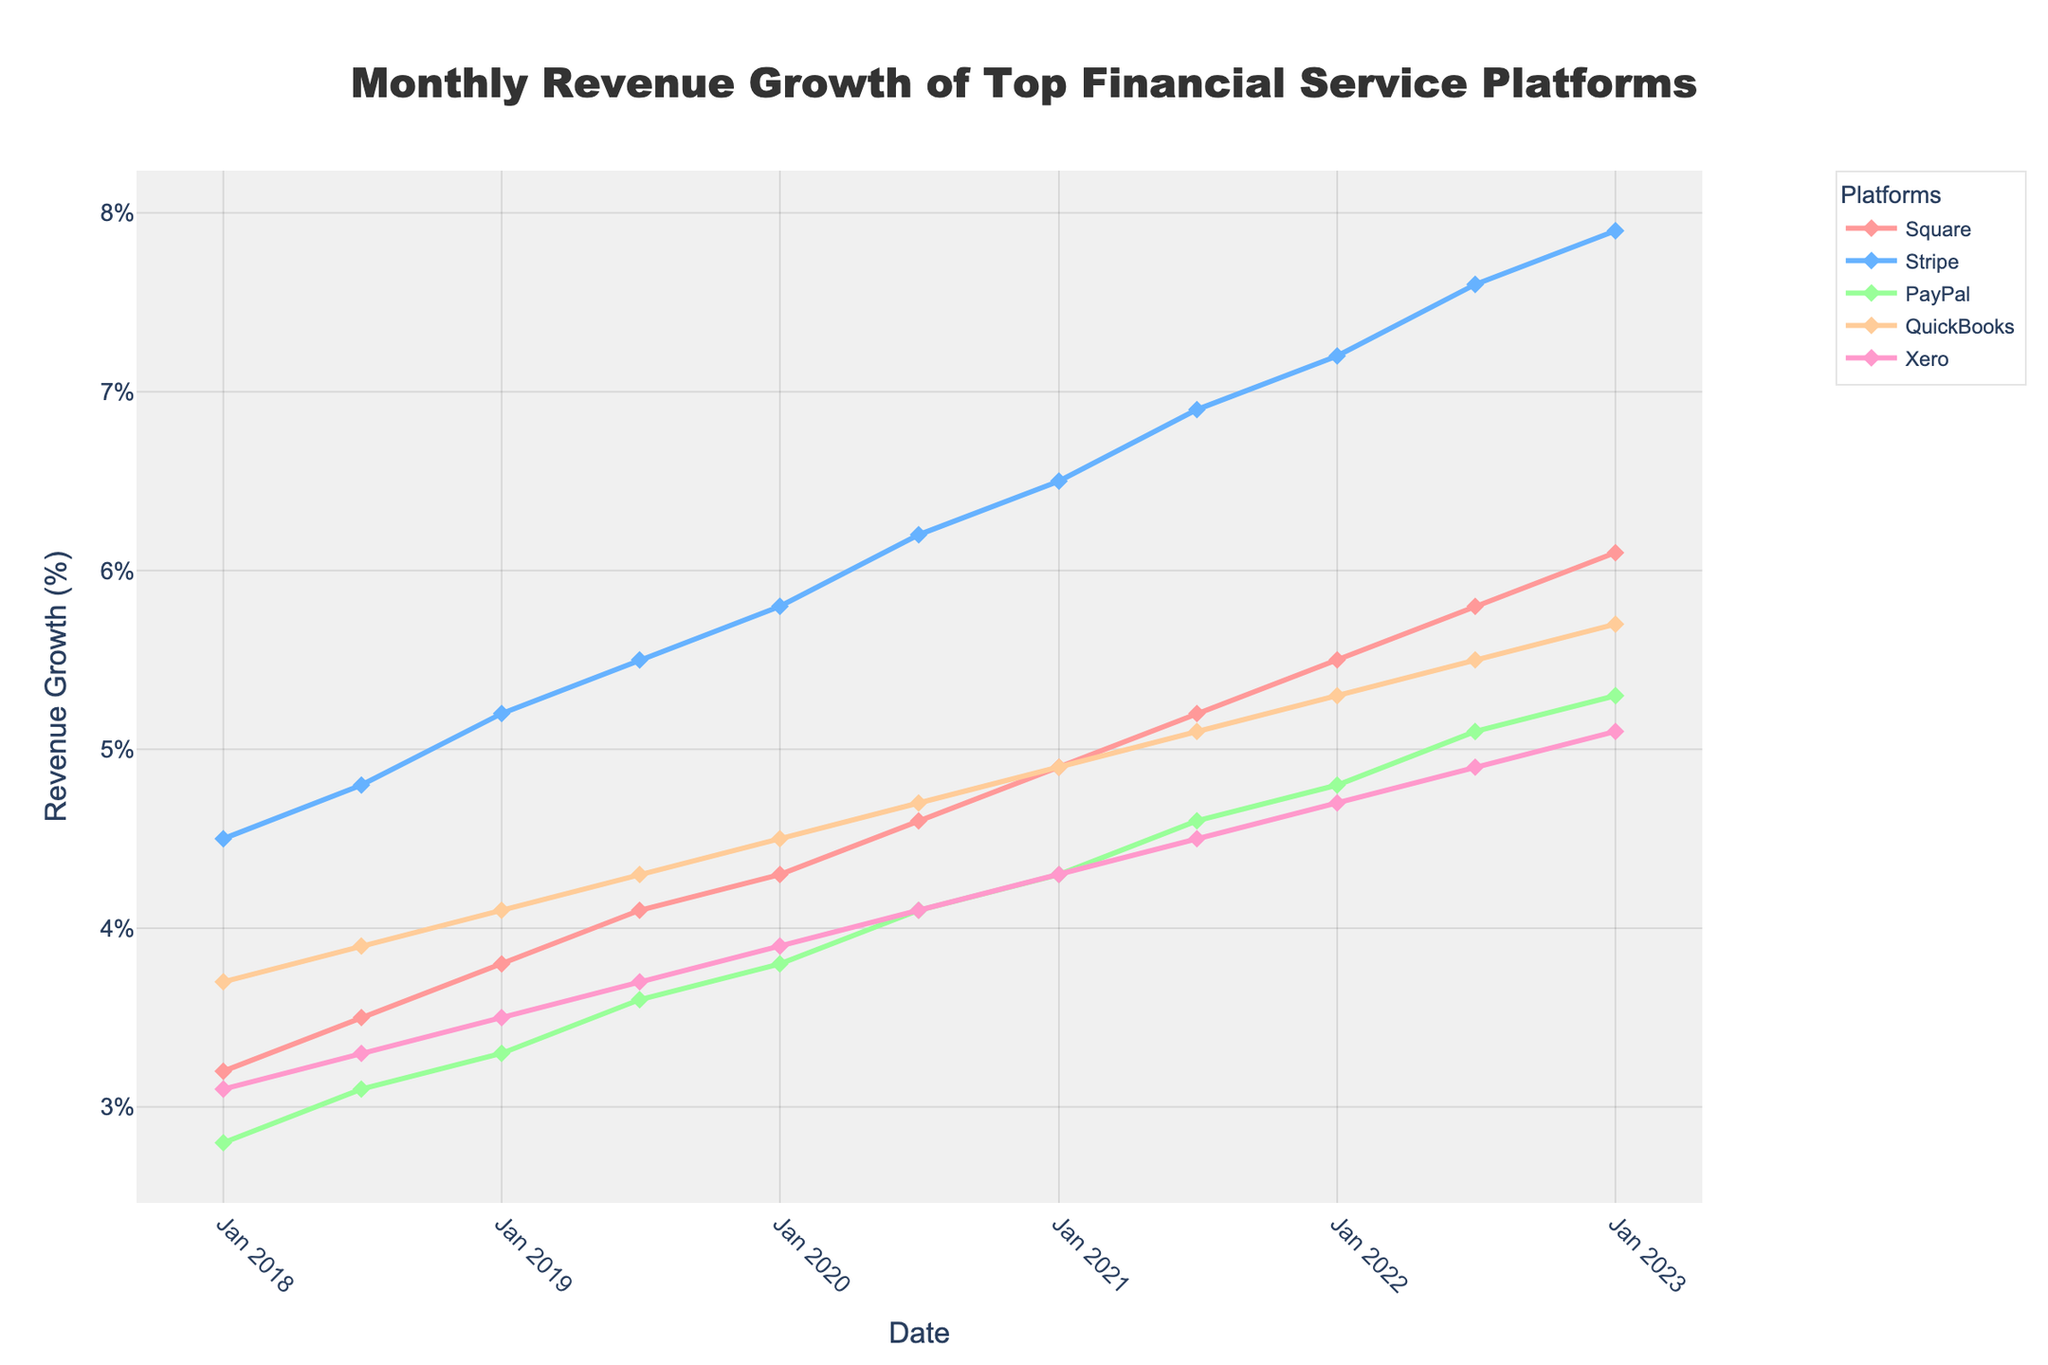What is the revenue growth of Square in January 2020? The point for Square in January 2020 is at 4.3% on the y-axis.
Answer: 4.3% Which platform had the highest revenue growth in January 2023? By looking at the graph, Stripe has the highest revenue growth point in January 2023, where the y-axis value is near 7.9%.
Answer: Stripe Which two platforms had identical revenue growth in January 2019? By examining January 2019, Square and QuickBooks both have growth rates that converge at around 4.1%.
Answer: QuickBooks and Square What's the average revenue growth for PayPal from 2018-2023? Add up all PayPal growth rates (2.8 + 3.1 + 3.3 + 3.6 + 3.8 + 4.1 + 4.3 + 4.6 + 4.8 + 5.1 + 5.3) and divide by 11. The sum is 44.9, so 44.9 / 11 = 4.08%.
Answer: 4.08% Which platform showed the greatest overall trend increase over the 5 years? Stripe showed the most evident consistent upward trend over the entire time span, starting around 4.5% and reaching up to 7.9%.
Answer: Stripe How many platforms had revenue growth above 5% in July 2022? In July 2022, Square, Stripe, and PayPal crossed the 5% growth mark. That counts as three platforms.
Answer: 3 What is the difference in revenue growth between PayPal and Xero in July 2021? In July 2021, PayPal had a growth rate of 4.6%, and Xero had 4.5%, so the difference is 4.6% - 4.5% = 0.1%.
Answer: 0.1% Did any platform have a decrease in revenue growth between January 2018 and January 2023? Every platform showed increasing values from 2018 to 2023, as all trend lines are upward.
Answer: No Which platform had the most volatile growth pattern over the timeline? By reviewing the ups and downs visually, PayPal seems to have the most varying pattern, with fluctuations between 2.8% and 5.3%.
Answer: PayPal What's the total growth increase for QuickBooks from January 2018 to January 2023? In January 2018, QuickBooks was at 3.7%, and by January 2023, it reached 5.7%. The difference is 5.7% - 3.7% = 2.0%.
Answer: 2.0% 